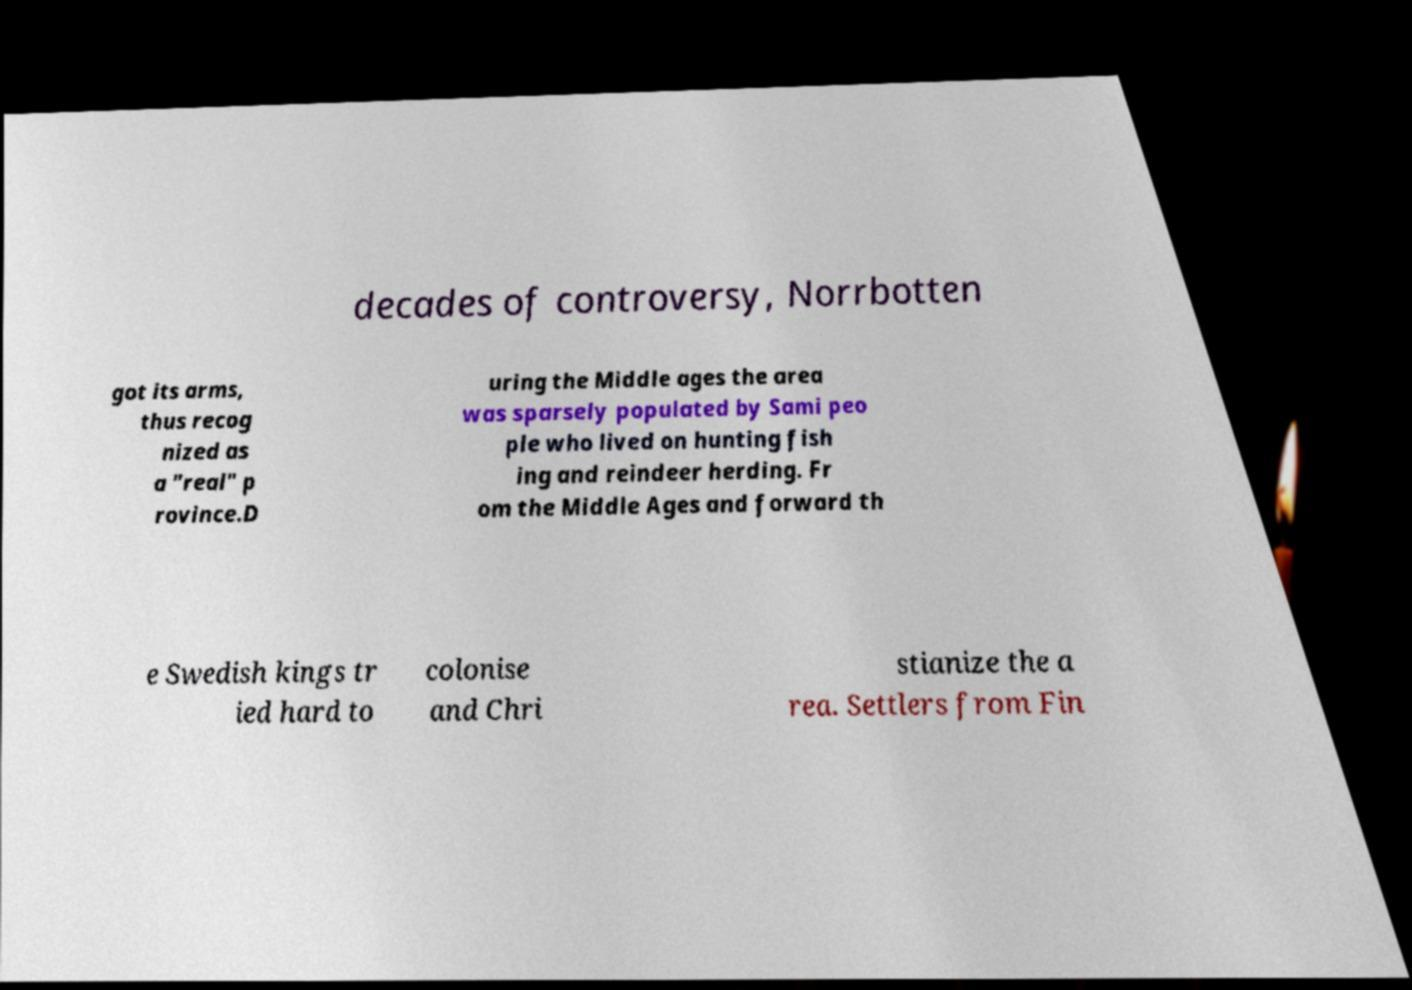I need the written content from this picture converted into text. Can you do that? decades of controversy, Norrbotten got its arms, thus recog nized as a "real" p rovince.D uring the Middle ages the area was sparsely populated by Sami peo ple who lived on hunting fish ing and reindeer herding. Fr om the Middle Ages and forward th e Swedish kings tr ied hard to colonise and Chri stianize the a rea. Settlers from Fin 